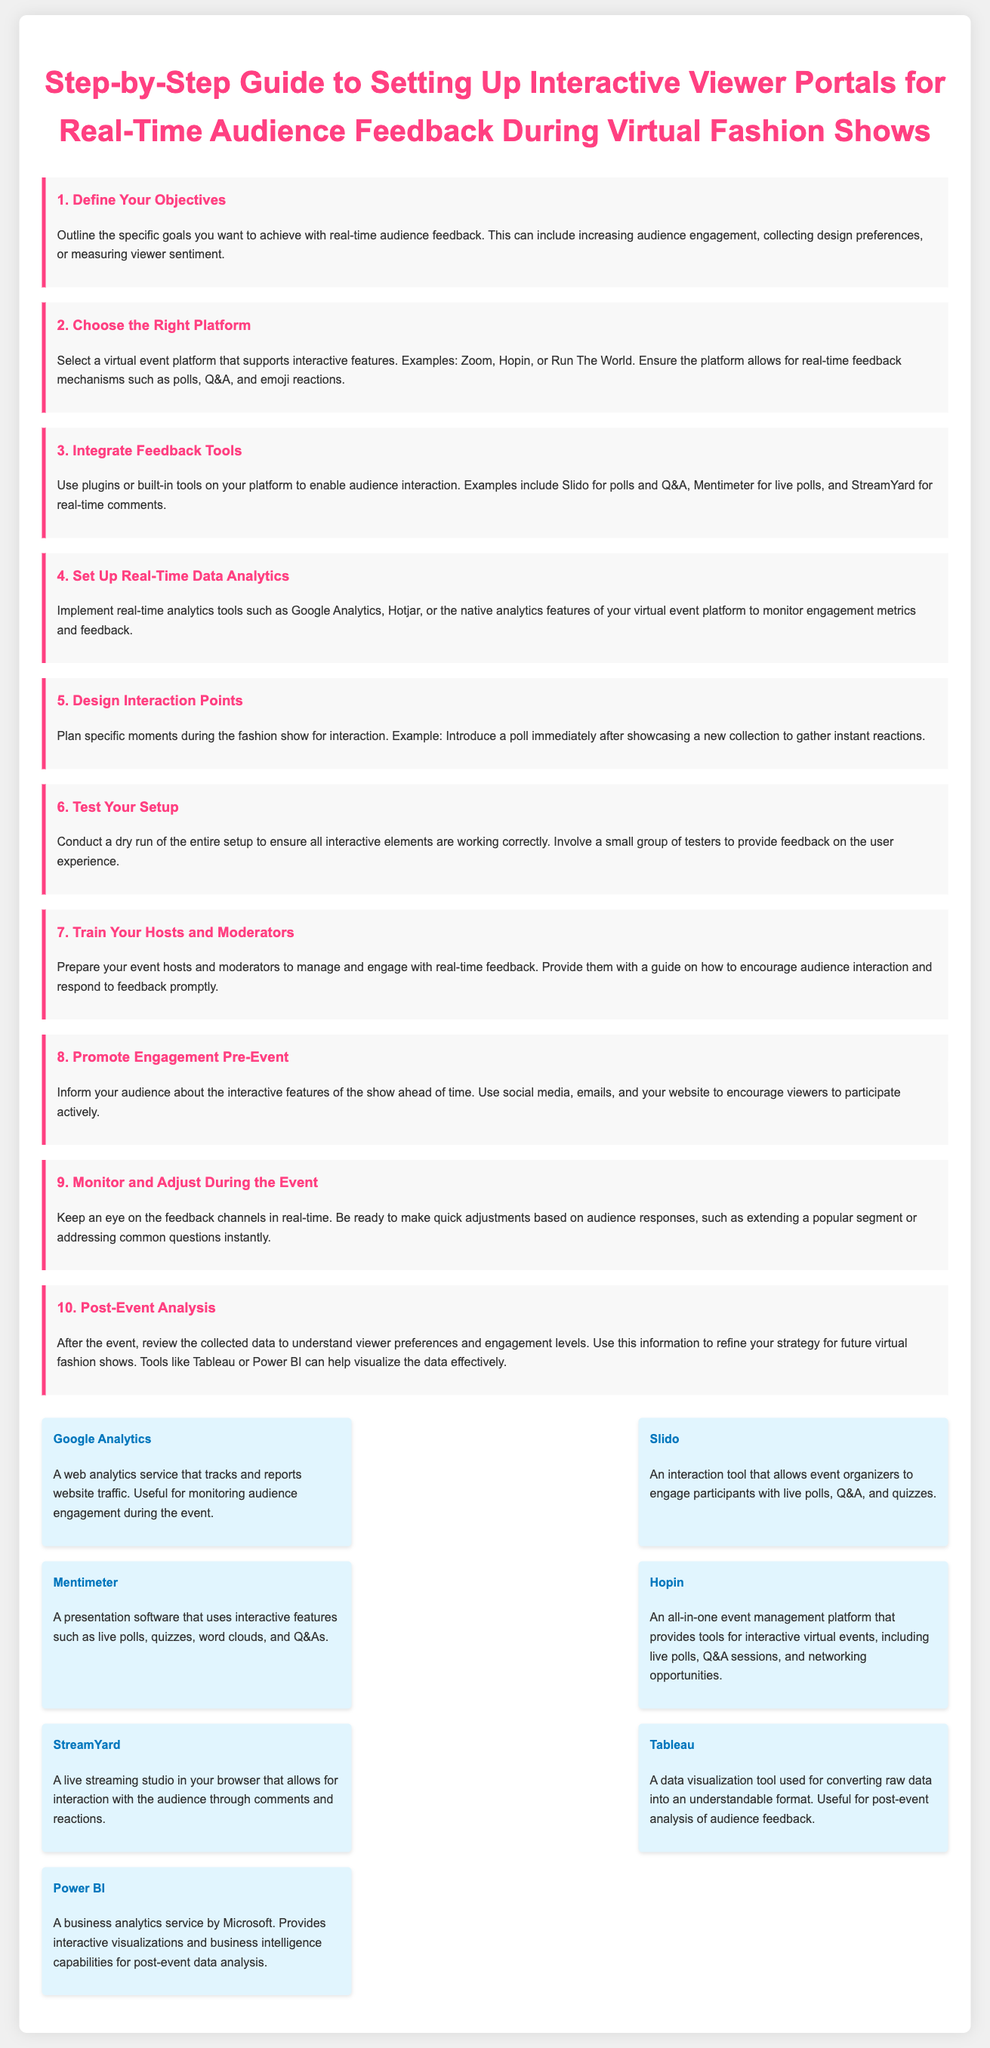what is the title of the document? The title of the document is the main heading found at the top of the content.
Answer: Step-by-Step Guide to Setting Up Interactive Viewer Portals for Real-Time Audience Feedback During Virtual Fashion Shows how many steps are outlined in the guide? The document lists a sequence of specific actions for setting up interactive viewer portals, which can be counted.
Answer: 10 which platform is suggested for engaging audience feedback? The document mentions various platforms that support interactive features for the fashion show setup.
Answer: Zoom name one tool mentioned for real-time analytics. The tools listed in the document include specific analytics services for monitoring engagement metrics during the event.
Answer: Google Analytics what should be conducted to ensure all interactive elements are working correctly? The document advises performing a specific preparation activity before the event to test the setup.
Answer: Dry run what is the main purpose of introducing a poll during the fashion show? The document explains the reason for placing interaction points in context with audience feedback after showcasing collections.
Answer: Gather instant reactions which tool is recommended for post-event data visualization? The document specifically mentions tools used to understand viewer preferences and engagement levels after the event.
Answer: Tableau how should hosts be prepared for the event? The document reiterates the importance of training in managing audience interaction and responding to feedback.
Answer: Training what is one way to promote engagement before the event? The document highlights methods for encouraging audience participation ahead of time using various communication channels.
Answer: Social media which interactive feature allows for live questions from the audience? The document identifies specific tools designed for engaging participants during the event.
Answer: Slido 